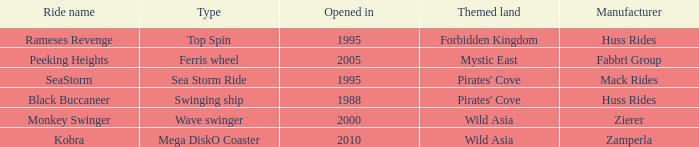What type of ride is Rameses Revenge? Top Spin. 